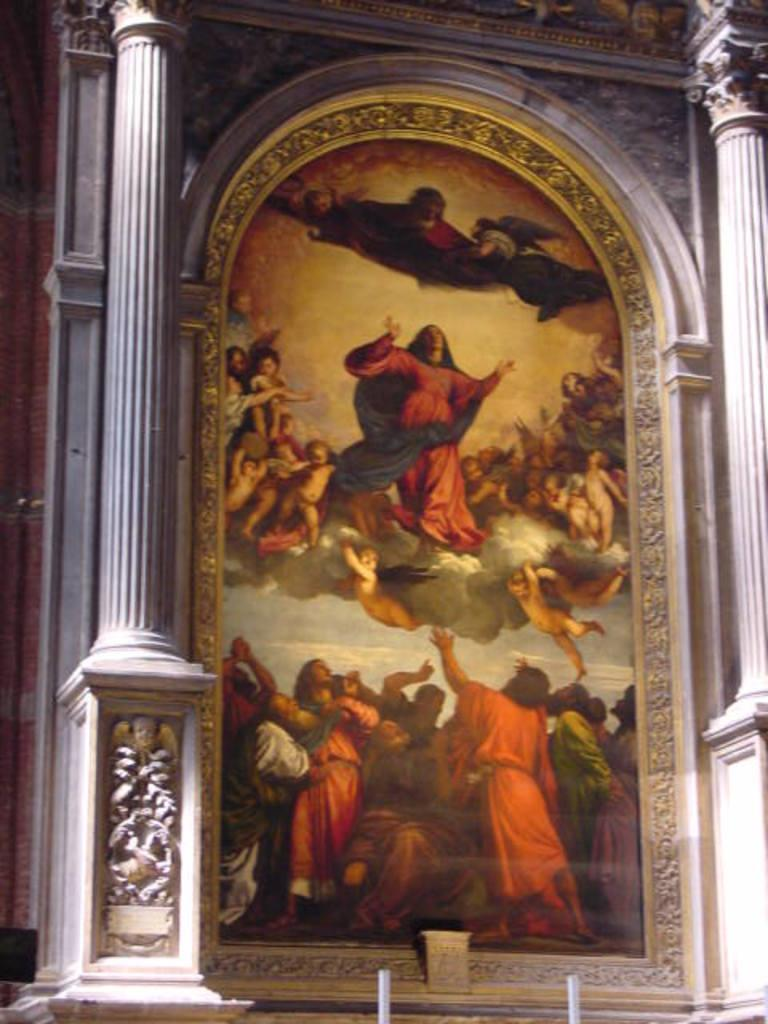What is hanging on the wall in the image? There is a photo frame on the wall in the image. What can be seen inside the photo frame? There is a group of people in the photo frame. What architectural features are visible in the image? There are pillars visible in the image. How much debt is represented by the pillars in the image? There is no indication of debt in the image, and the pillars are architectural features rather than financial representations. 